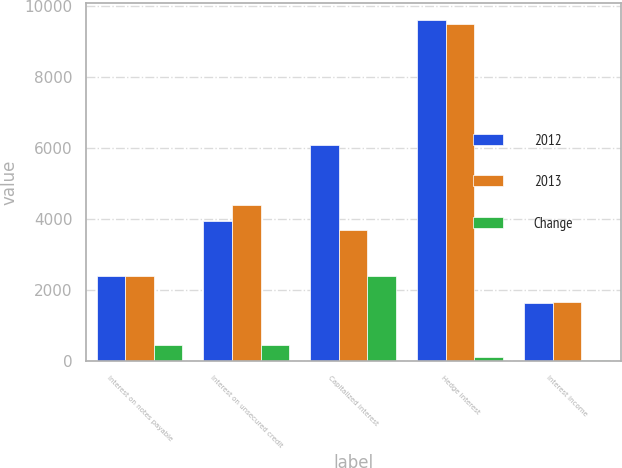Convert chart to OTSL. <chart><loc_0><loc_0><loc_500><loc_500><stacked_bar_chart><ecel><fcel>Interest on notes payable<fcel>Interest on unsecured credit<fcel>Capitalized interest<fcel>Hedge interest<fcel>Interest income<nl><fcel>2012<fcel>2392<fcel>3937<fcel>6078<fcel>9607<fcel>1643<nl><fcel>2013<fcel>2392<fcel>4388<fcel>3686<fcel>9492<fcel>1675<nl><fcel>Change<fcel>467<fcel>451<fcel>2392<fcel>115<fcel>32<nl></chart> 